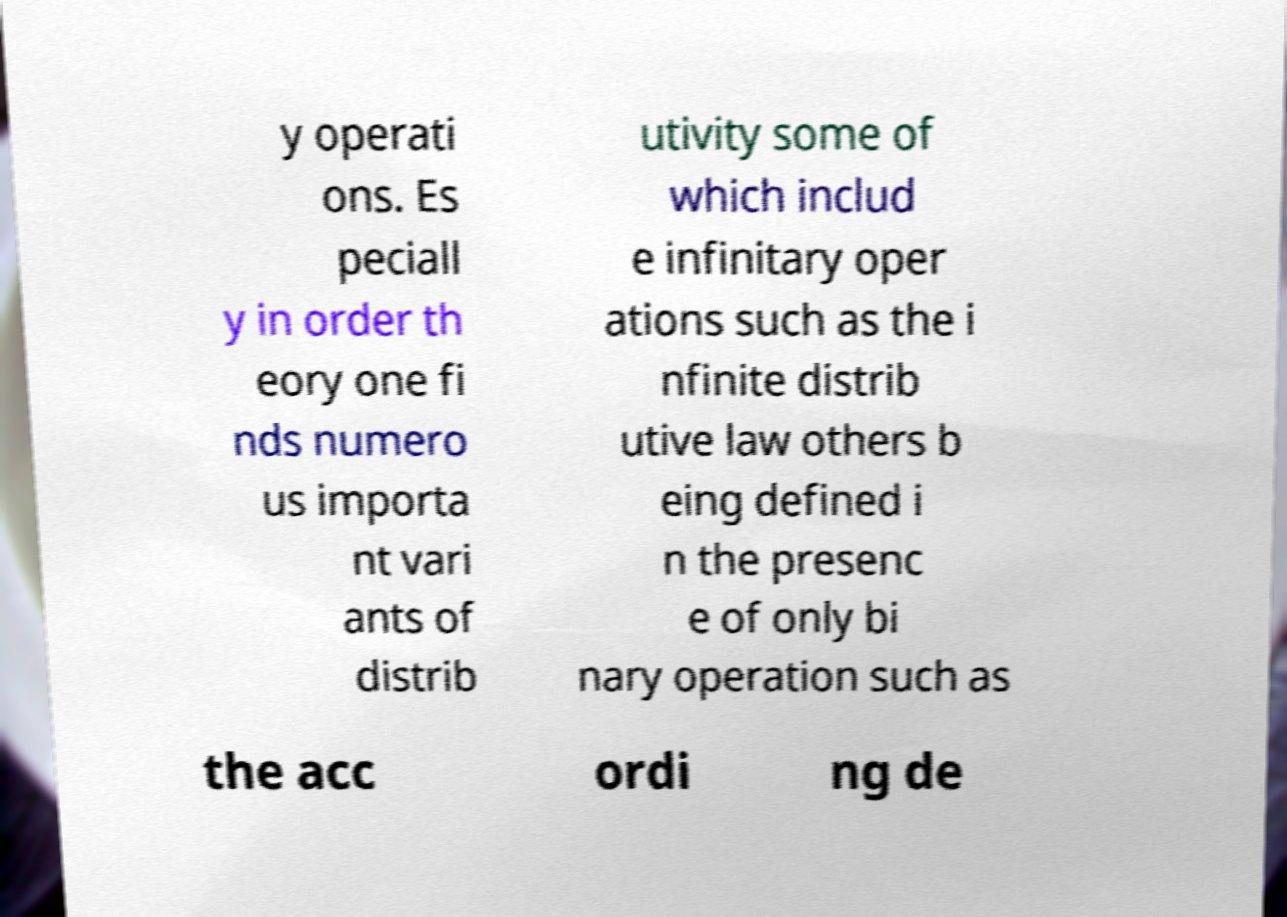Could you extract and type out the text from this image? y operati ons. Es peciall y in order th eory one fi nds numero us importa nt vari ants of distrib utivity some of which includ e infinitary oper ations such as the i nfinite distrib utive law others b eing defined i n the presenc e of only bi nary operation such as the acc ordi ng de 